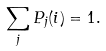Convert formula to latex. <formula><loc_0><loc_0><loc_500><loc_500>\sum _ { j } P _ { j } ( i ) = 1 .</formula> 